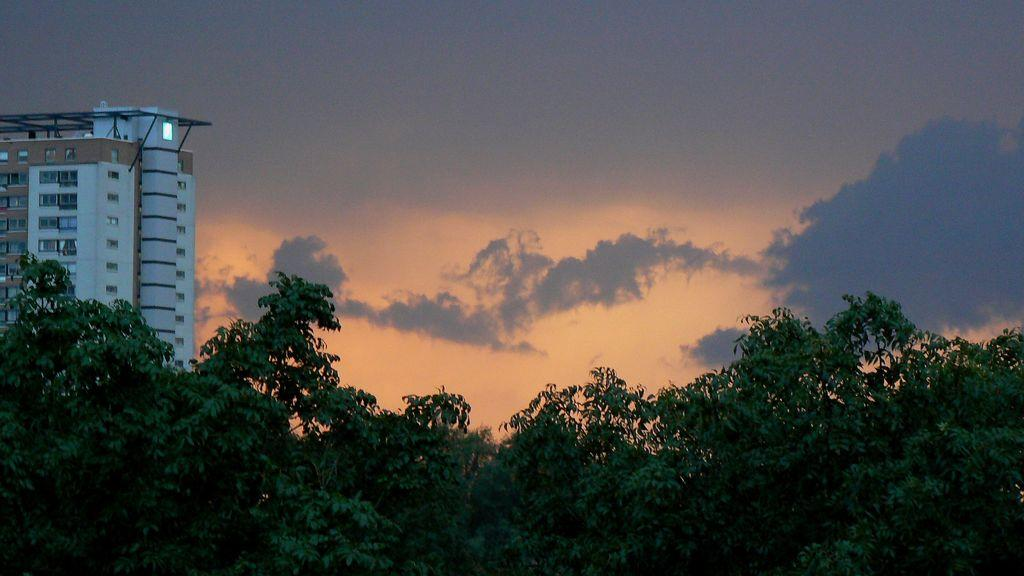What type of vegetation can be seen in the image? There are trees in the image. What type of structure is present in the image? There is a building in the image. What part of the natural environment is visible in the image? The sky is visible in the image. What type of hospital can be seen in the image? There is no hospital present in the image; it features trees and a building. How does the sand contribute to the image? There is no sand present in the image. 